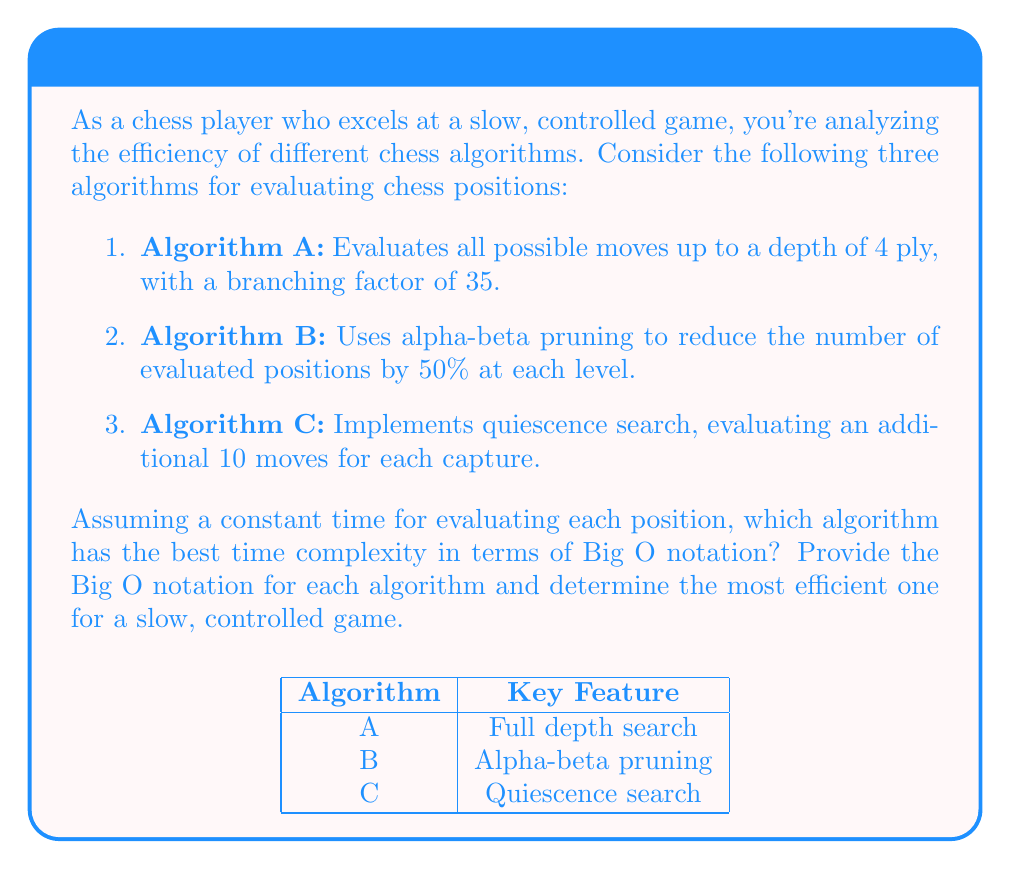Can you solve this math problem? Let's analyze each algorithm step-by-step:

1. Algorithm A:
   - This is a basic minimax algorithm with a fixed depth.
   - Number of positions evaluated: $35^4 = 1,500,625$
   - Time complexity: $O(b^d)$, where $b$ is the branching factor (35) and $d$ is the depth (4)
   - Thus, the complexity is $O(35^4)$ or $O(1,500,625)$

2. Algorithm B:
   - Using alpha-beta pruning reduces the number of evaluated positions by 50% at each level.
   - Effective branching factor: $\sqrt{35} \approx 5.92$
   - Number of positions evaluated: $5.92^4 \approx 1,225$
   - Time complexity: $O(\sqrt{b}^d)$, where $b$ is the original branching factor (35) and $d$ is the depth (4)
   - Thus, the complexity is $O(5.92^4)$ or $O(1,225)$

3. Algorithm C:
   - Implements quiescence search, which extends the search for capture moves.
   - Assuming worst case where all leaf nodes have captures:
     Base positions: $35^4 = 1,500,625$
     Additional positions due to quiescence: $1,500,625 * 10 = 15,006,250$
   - Total positions evaluated: $1,500,625 + 15,006,250 = 16,506,875$
   - Time complexity: $O(b^d + b^d * q)$, where $b$ is the branching factor (35), $d$ is the depth (4), and $q$ is the number of quiescence moves (10)
   - Thus, the complexity is $O(35^4 * 11)$ or $O(16,506,875)$

Comparing the time complexities:
- Algorithm A: $O(1,500,625)$
- Algorithm B: $O(1,225)$
- Algorithm C: $O(16,506,875)$

Algorithm B has the best (lowest) time complexity among the three.

For a slow, controlled game, Algorithm B with alpha-beta pruning would be the most efficient. It significantly reduces the number of positions evaluated while maintaining a good search depth. This aligns well with a player who prefers a methodical approach, as it allows for deeper analysis without excessive computational overhead.
Answer: Algorithm B: $O(\sqrt{b}^d)$ 